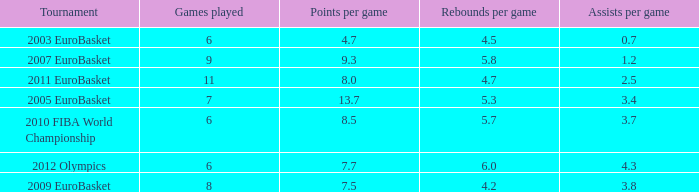How many assists per game have 4.2 rebounds per game? 3.8. 